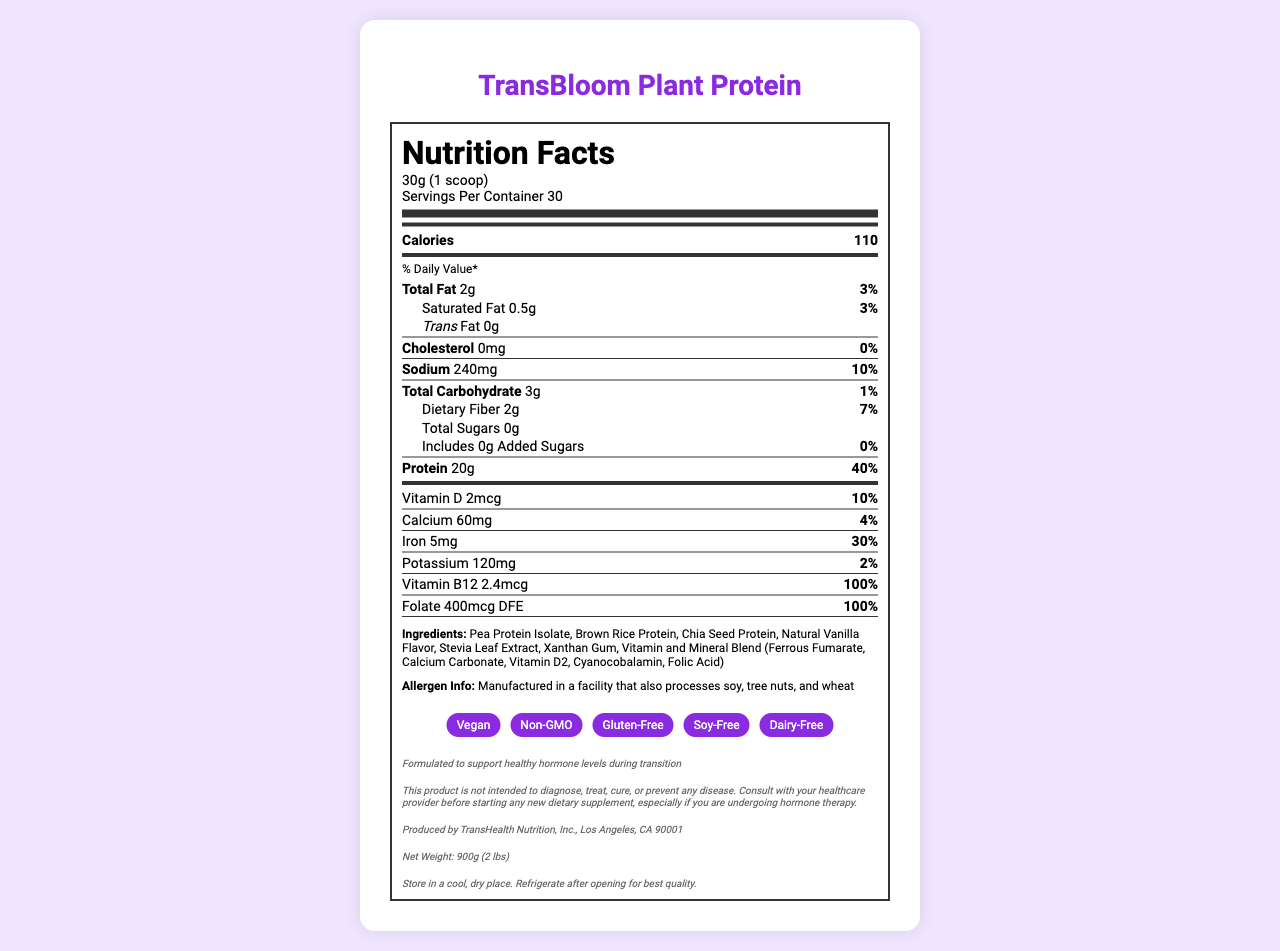what is the serving size? The serving size is clearly mentioned at the beginning of the nutrition label: "30g (1 scoop)".
Answer: 30g (1 scoop) how many servings are in each container? The number of servings per container is explicitly mentioned as 30 in the serving information section.
Answer: 30 what is the amount of protein per serving? The document specifies that each serving contains 20g of protein, which is also 40% of the daily value.
Answer: 20g does this product contain any trans fat? The label states "Trans Fat 0g", indicating that there is no trans fat in the product.
Answer: No what vitamins and minerals are included in this protein powder? The label lists these vitamins and minerals along with their amounts and daily values.
Answer: Vitamin D, Calcium, Iron, Potassium, Vitamin B12, Folate which ingredient is not in the list? A. Pea Protein Isolate B. Brown Rice Protein C. Soy Protein D. Chia Seed Protein The list of ingredients does not mention "Soy Protein".
Answer: C how much sodium does one serving contain? A. 200mg B. 240mg C. 260mg D. 280mg According to the label, one serving contains 240mg of sodium, which is 10% of the daily value.
Answer: B is this product gluten-free? The special features section lists "Gluten-Free" as one of the product attributes.
Answer: Yes is there any added sugar in the product? The label mentions "Includes 0g Added Sugars" and "0%" as the daily value for added sugars.
Answer: No summarize the main purpose and features of the TransBloom Plant Protein. This summary captures the key features, nutritional information, and special considerations listed in the document.
Answer: The TransBloom Plant Protein is a plant-based protein powder designed for transgender individuals. It supports healthy hormone levels during transition, offers 20g of protein per serving, and is enriched with essential vitamins and minerals. The product is vegan, non-GMO, gluten-free, soy-free, and dairy-free. It contains no added sugars and is manufactured in a facility that processes soy, tree nuts, and wheat. what is the exact amount of vitamin D in each serving? The label specifies that each serving contains 2mcg of vitamin D, which is 10% of the daily value.
Answer: 2mcg is this product safe for someone with a wheat allergy? The document indicates that the product is manufactured in a facility that processes wheat, which can pose a risk for those with wheat allergies.
Answer: No how much folate is included per serving, in mcg of DFE? The label indicates that each serving contains 400mcg DFE of folate, which is 100% of the daily value.
Answer: 400mcg where is TransBloom Plant Protein manufactured? The document lists the manufacturer information as "Produced by TransHealth Nutrition, Inc., Los Angeles, CA 90001".
Answer: Los Angeles, CA 90001 how many calories are there in one serving? The calorie content per serving is clearly listed as 110 calories.
Answer: 110 which ingredient helps sweeten the product? Stevia Leaf Extract is likely used as the sweetener, as it is listed among the ingredients.
Answer: Stevia Leaf Extract can you identify if this product supports muscle recovery post-exercise? The document provides nutritional information and special features but does not specifically mention muscle recovery support.
Answer: Cannot be determined 